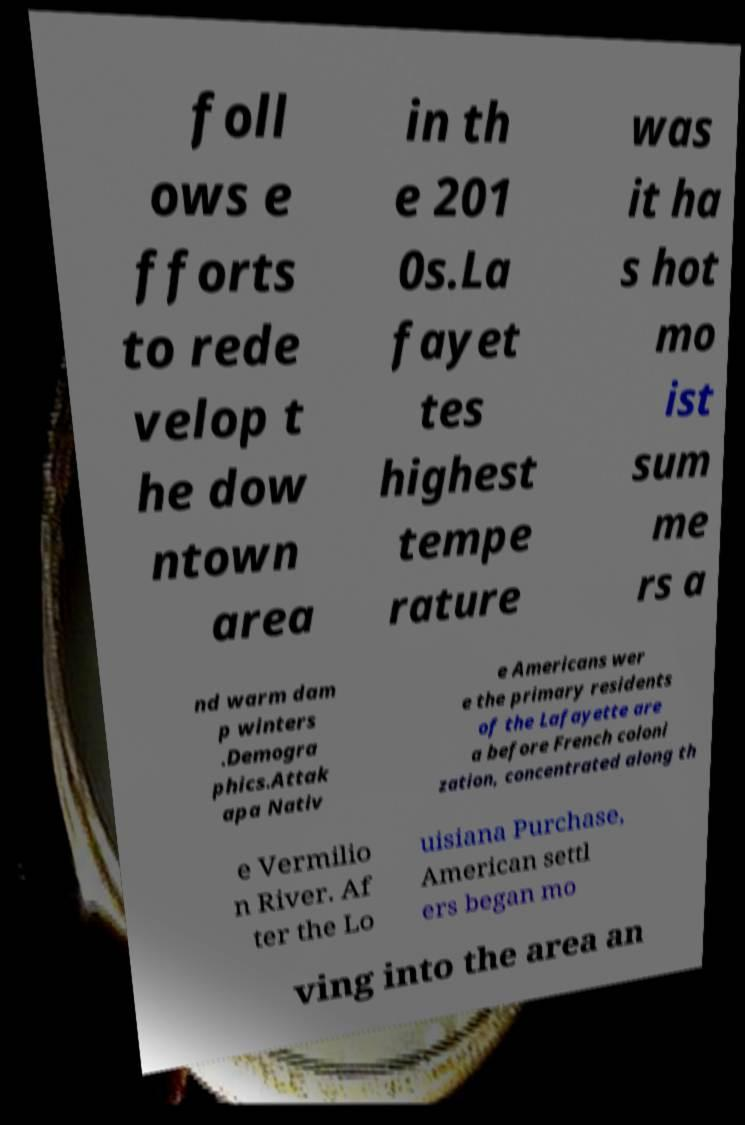Can you accurately transcribe the text from the provided image for me? foll ows e fforts to rede velop t he dow ntown area in th e 201 0s.La fayet tes highest tempe rature was it ha s hot mo ist sum me rs a nd warm dam p winters .Demogra phics.Attak apa Nativ e Americans wer e the primary residents of the Lafayette are a before French coloni zation, concentrated along th e Vermilio n River. Af ter the Lo uisiana Purchase, American settl ers began mo ving into the area an 